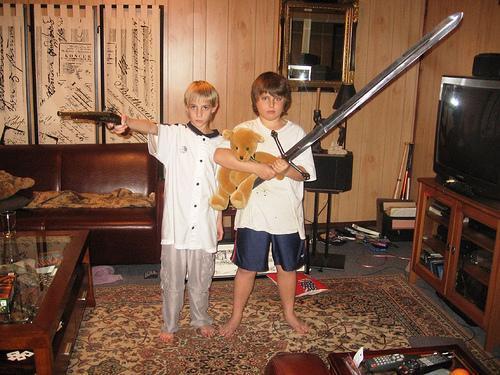How many people are in the room?
Give a very brief answer. 2. How many televisions are in the photo?
Give a very brief answer. 1. How many coffee tables are in the room?
Give a very brief answer. 1. How many bats are there?
Give a very brief answer. 0. How many people are in the picture?
Give a very brief answer. 2. How many birds are in the photo?
Give a very brief answer. 0. 